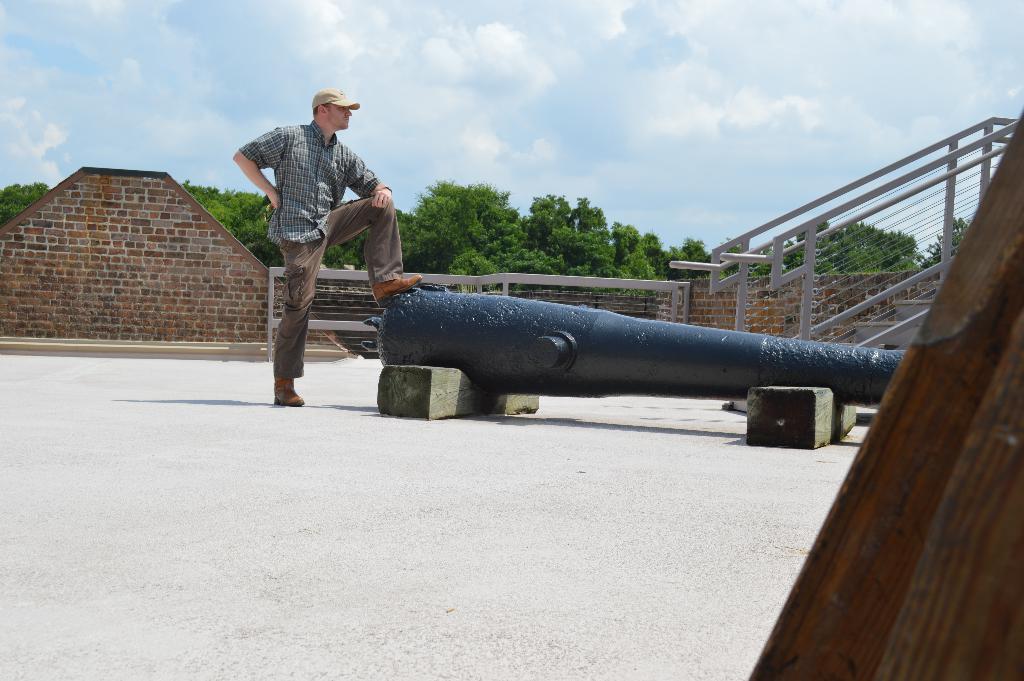Could you give a brief overview of what you see in this image? In this image I can see the person and the person is wearing blue and brown color dress and I can also see the cannon. Background I can see few stairs and the wall is in brown color and I can also see few trees in green color and the sky is in blue and white color. 